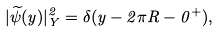Convert formula to latex. <formula><loc_0><loc_0><loc_500><loc_500>| \widetilde { \psi } ( y ) | ^ { 2 } _ { Y } = \delta ( y - 2 \pi R - 0 ^ { + } ) ,</formula> 